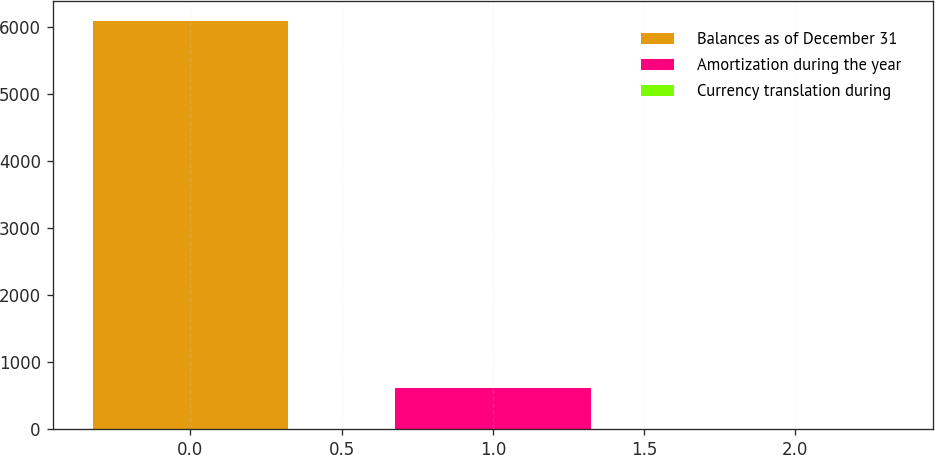<chart> <loc_0><loc_0><loc_500><loc_500><bar_chart><fcel>Balances as of December 31<fcel>Amortization during the year<fcel>Currency translation during<nl><fcel>6084<fcel>615.6<fcel>8<nl></chart> 